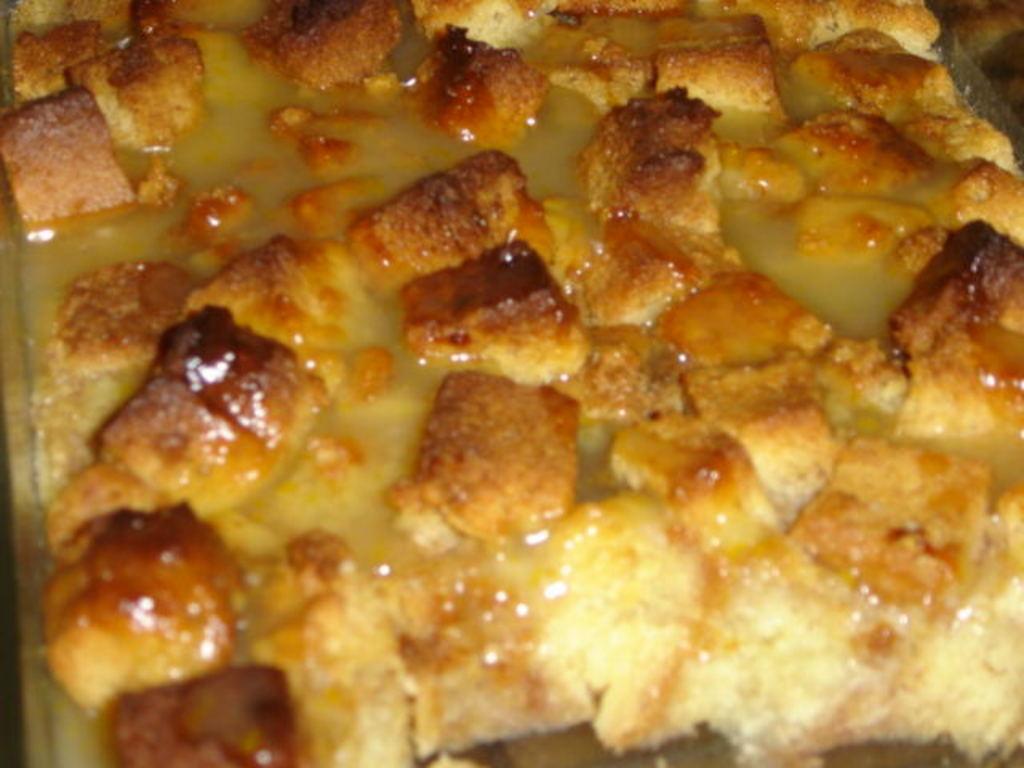Describe this image in one or two sentences. In this image we can see a food item. 